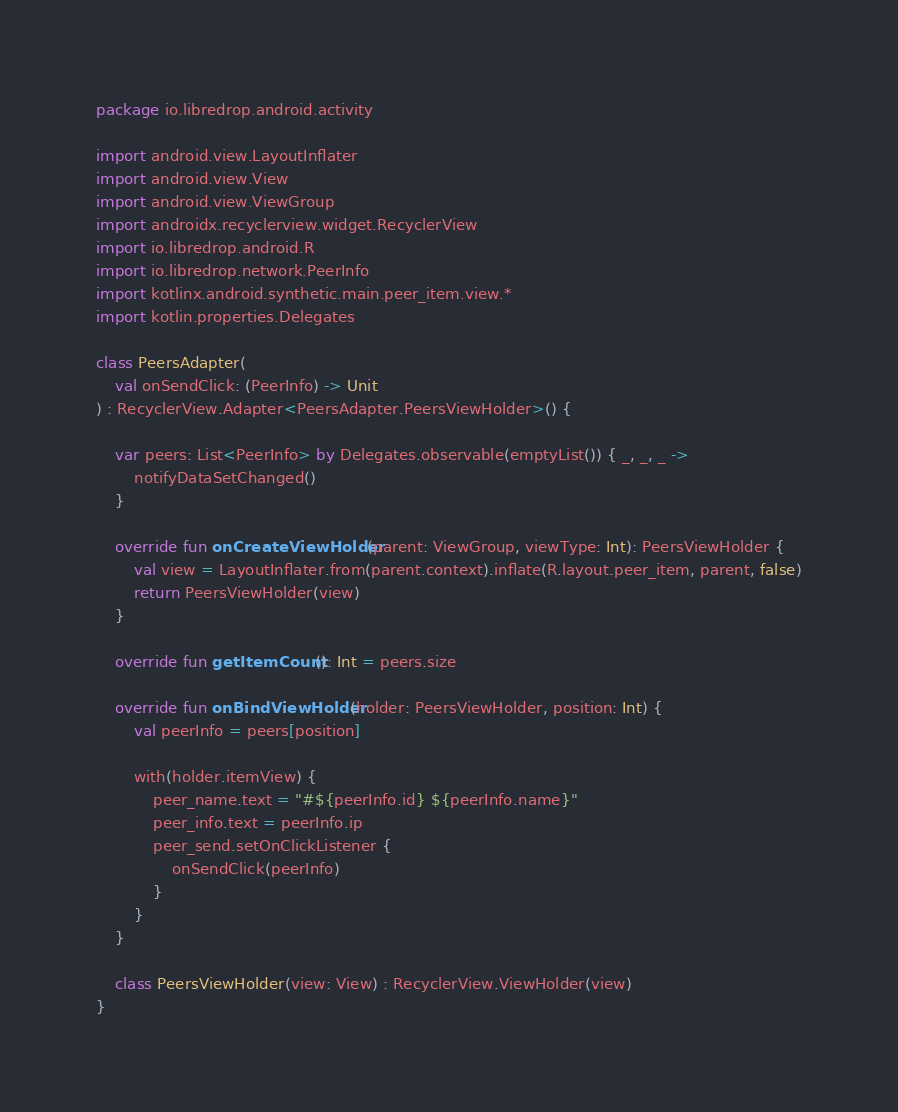<code> <loc_0><loc_0><loc_500><loc_500><_Kotlin_>package io.libredrop.android.activity

import android.view.LayoutInflater
import android.view.View
import android.view.ViewGroup
import androidx.recyclerview.widget.RecyclerView
import io.libredrop.android.R
import io.libredrop.network.PeerInfo
import kotlinx.android.synthetic.main.peer_item.view.*
import kotlin.properties.Delegates

class PeersAdapter(
    val onSendClick: (PeerInfo) -> Unit
) : RecyclerView.Adapter<PeersAdapter.PeersViewHolder>() {

    var peers: List<PeerInfo> by Delegates.observable(emptyList()) { _, _, _ ->
        notifyDataSetChanged()
    }

    override fun onCreateViewHolder(parent: ViewGroup, viewType: Int): PeersViewHolder {
        val view = LayoutInflater.from(parent.context).inflate(R.layout.peer_item, parent, false)
        return PeersViewHolder(view)
    }

    override fun getItemCount(): Int = peers.size

    override fun onBindViewHolder(holder: PeersViewHolder, position: Int) {
        val peerInfo = peers[position]

        with(holder.itemView) {
            peer_name.text = "#${peerInfo.id} ${peerInfo.name}"
            peer_info.text = peerInfo.ip
            peer_send.setOnClickListener {
                onSendClick(peerInfo)
            }
        }
    }

    class PeersViewHolder(view: View) : RecyclerView.ViewHolder(view)
}
</code> 